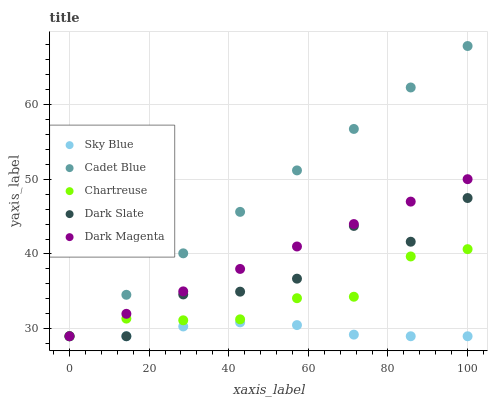Does Sky Blue have the minimum area under the curve?
Answer yes or no. Yes. Does Cadet Blue have the maximum area under the curve?
Answer yes or no. Yes. Does Chartreuse have the minimum area under the curve?
Answer yes or no. No. Does Chartreuse have the maximum area under the curve?
Answer yes or no. No. Is Dark Magenta the smoothest?
Answer yes or no. Yes. Is Dark Slate the roughest?
Answer yes or no. Yes. Is Chartreuse the smoothest?
Answer yes or no. No. Is Chartreuse the roughest?
Answer yes or no. No. Does Sky Blue have the lowest value?
Answer yes or no. Yes. Does Cadet Blue have the highest value?
Answer yes or no. Yes. Does Chartreuse have the highest value?
Answer yes or no. No. Does Chartreuse intersect Cadet Blue?
Answer yes or no. Yes. Is Chartreuse less than Cadet Blue?
Answer yes or no. No. Is Chartreuse greater than Cadet Blue?
Answer yes or no. No. 